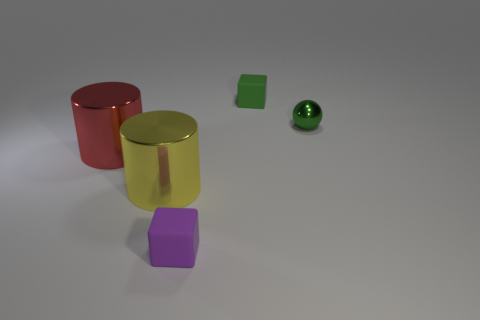There is a tiny object that is the same color as the shiny ball; what is its material?
Keep it short and to the point. Rubber. There is a green metal thing that is the same size as the purple rubber thing; what shape is it?
Ensure brevity in your answer.  Sphere. Is there anything else that is the same color as the shiny sphere?
Your answer should be compact. Yes. What is the size of the cylinder that is the same material as the large red thing?
Offer a terse response. Large. Do the yellow thing and the tiny object behind the small green ball have the same shape?
Provide a short and direct response. No. The green sphere has what size?
Make the answer very short. Small. Is the number of balls left of the tiny green rubber thing less than the number of blue matte objects?
Ensure brevity in your answer.  No. What number of cylinders have the same size as the green shiny object?
Provide a succinct answer. 0. What shape is the small rubber thing that is the same color as the small metallic thing?
Provide a short and direct response. Cube. Is the color of the matte cube that is in front of the small metallic ball the same as the tiny matte object that is behind the green metal object?
Keep it short and to the point. No. 